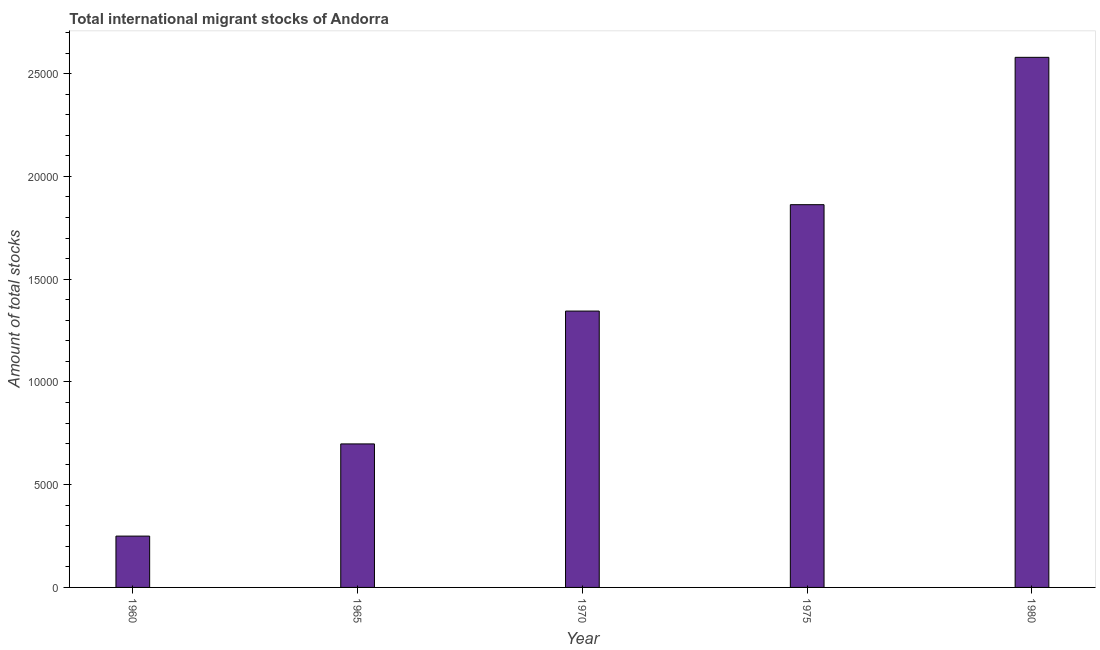Does the graph contain any zero values?
Give a very brief answer. No. What is the title of the graph?
Provide a short and direct response. Total international migrant stocks of Andorra. What is the label or title of the Y-axis?
Keep it short and to the point. Amount of total stocks. What is the total number of international migrant stock in 1970?
Offer a terse response. 1.34e+04. Across all years, what is the maximum total number of international migrant stock?
Make the answer very short. 2.58e+04. Across all years, what is the minimum total number of international migrant stock?
Your answer should be compact. 2497. In which year was the total number of international migrant stock maximum?
Provide a short and direct response. 1980. What is the sum of the total number of international migrant stock?
Provide a short and direct response. 6.73e+04. What is the difference between the total number of international migrant stock in 1975 and 1980?
Offer a very short reply. -7169. What is the average total number of international migrant stock per year?
Your answer should be very brief. 1.35e+04. What is the median total number of international migrant stock?
Your response must be concise. 1.34e+04. In how many years, is the total number of international migrant stock greater than 12000 ?
Offer a very short reply. 3. Do a majority of the years between 1980 and 1970 (inclusive) have total number of international migrant stock greater than 20000 ?
Provide a succinct answer. Yes. What is the ratio of the total number of international migrant stock in 1960 to that in 1965?
Make the answer very short. 0.36. Is the total number of international migrant stock in 1960 less than that in 1980?
Your answer should be very brief. Yes. Is the difference between the total number of international migrant stock in 1965 and 1980 greater than the difference between any two years?
Ensure brevity in your answer.  No. What is the difference between the highest and the second highest total number of international migrant stock?
Offer a very short reply. 7169. Is the sum of the total number of international migrant stock in 1960 and 1965 greater than the maximum total number of international migrant stock across all years?
Provide a short and direct response. No. What is the difference between the highest and the lowest total number of international migrant stock?
Your answer should be compact. 2.33e+04. In how many years, is the total number of international migrant stock greater than the average total number of international migrant stock taken over all years?
Provide a succinct answer. 2. Are all the bars in the graph horizontal?
Give a very brief answer. No. How many years are there in the graph?
Your answer should be compact. 5. What is the difference between two consecutive major ticks on the Y-axis?
Your answer should be very brief. 5000. Are the values on the major ticks of Y-axis written in scientific E-notation?
Provide a short and direct response. No. What is the Amount of total stocks in 1960?
Offer a very short reply. 2497. What is the Amount of total stocks in 1965?
Your answer should be compact. 6983. What is the Amount of total stocks in 1970?
Provide a short and direct response. 1.34e+04. What is the Amount of total stocks in 1975?
Your answer should be compact. 1.86e+04. What is the Amount of total stocks of 1980?
Your answer should be very brief. 2.58e+04. What is the difference between the Amount of total stocks in 1960 and 1965?
Offer a very short reply. -4486. What is the difference between the Amount of total stocks in 1960 and 1970?
Your answer should be very brief. -1.09e+04. What is the difference between the Amount of total stocks in 1960 and 1975?
Provide a short and direct response. -1.61e+04. What is the difference between the Amount of total stocks in 1960 and 1980?
Your response must be concise. -2.33e+04. What is the difference between the Amount of total stocks in 1965 and 1970?
Offer a very short reply. -6463. What is the difference between the Amount of total stocks in 1965 and 1975?
Your answer should be compact. -1.16e+04. What is the difference between the Amount of total stocks in 1965 and 1980?
Your response must be concise. -1.88e+04. What is the difference between the Amount of total stocks in 1970 and 1975?
Give a very brief answer. -5177. What is the difference between the Amount of total stocks in 1970 and 1980?
Your answer should be compact. -1.23e+04. What is the difference between the Amount of total stocks in 1975 and 1980?
Offer a terse response. -7169. What is the ratio of the Amount of total stocks in 1960 to that in 1965?
Your answer should be very brief. 0.36. What is the ratio of the Amount of total stocks in 1960 to that in 1970?
Offer a terse response. 0.19. What is the ratio of the Amount of total stocks in 1960 to that in 1975?
Your response must be concise. 0.13. What is the ratio of the Amount of total stocks in 1960 to that in 1980?
Provide a short and direct response. 0.1. What is the ratio of the Amount of total stocks in 1965 to that in 1970?
Give a very brief answer. 0.52. What is the ratio of the Amount of total stocks in 1965 to that in 1980?
Your response must be concise. 0.27. What is the ratio of the Amount of total stocks in 1970 to that in 1975?
Give a very brief answer. 0.72. What is the ratio of the Amount of total stocks in 1970 to that in 1980?
Make the answer very short. 0.52. What is the ratio of the Amount of total stocks in 1975 to that in 1980?
Offer a terse response. 0.72. 